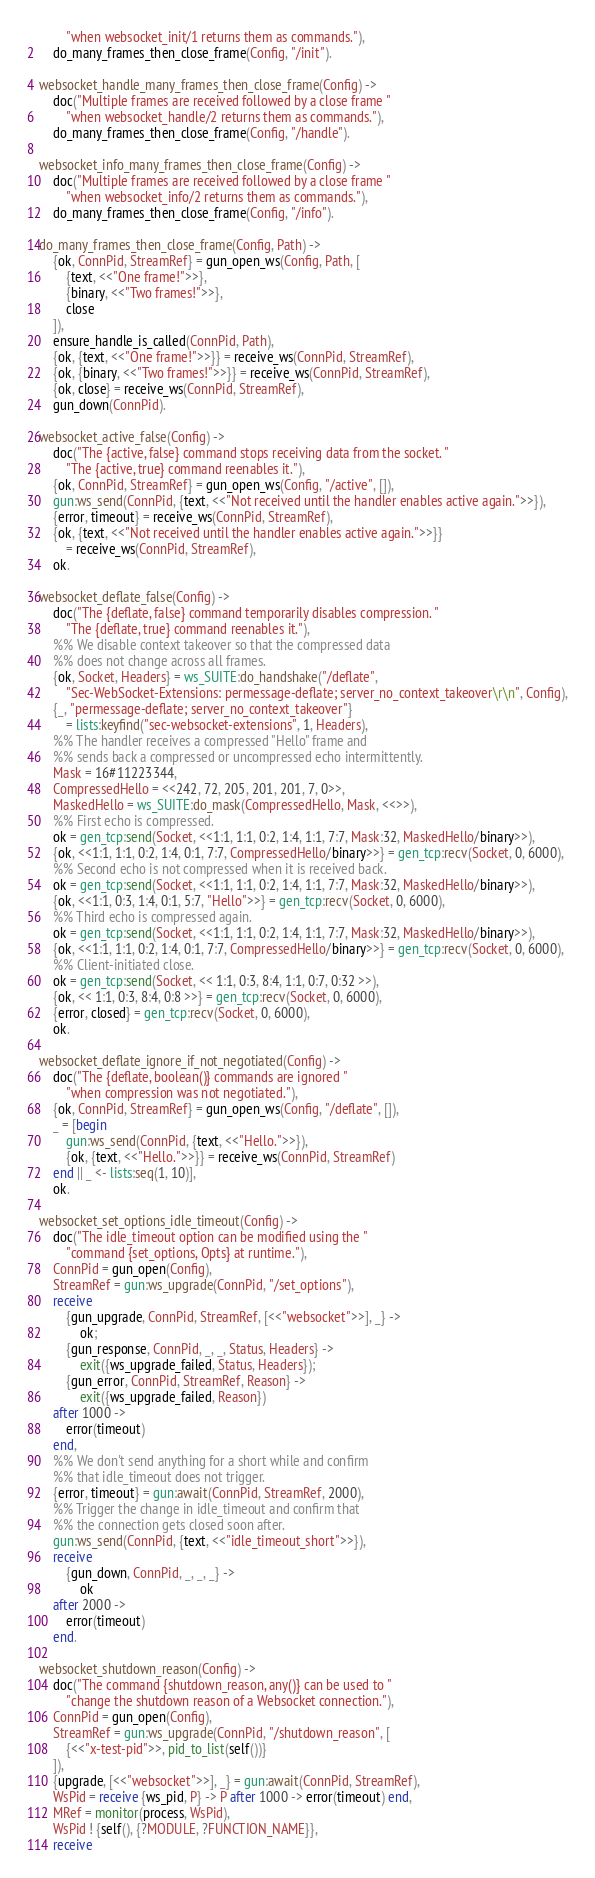<code> <loc_0><loc_0><loc_500><loc_500><_Erlang_>		"when websocket_init/1 returns them as commands."),
	do_many_frames_then_close_frame(Config, "/init").

websocket_handle_many_frames_then_close_frame(Config) ->
	doc("Multiple frames are received followed by a close frame "
		"when websocket_handle/2 returns them as commands."),
	do_many_frames_then_close_frame(Config, "/handle").

websocket_info_many_frames_then_close_frame(Config) ->
	doc("Multiple frames are received followed by a close frame "
		"when websocket_info/2 returns them as commands."),
	do_many_frames_then_close_frame(Config, "/info").

do_many_frames_then_close_frame(Config, Path) ->
	{ok, ConnPid, StreamRef} = gun_open_ws(Config, Path, [
		{text, <<"One frame!">>},
		{binary, <<"Two frames!">>},
		close
	]),
	ensure_handle_is_called(ConnPid, Path),
	{ok, {text, <<"One frame!">>}} = receive_ws(ConnPid, StreamRef),
	{ok, {binary, <<"Two frames!">>}} = receive_ws(ConnPid, StreamRef),
	{ok, close} = receive_ws(ConnPid, StreamRef),
	gun_down(ConnPid).

websocket_active_false(Config) ->
	doc("The {active, false} command stops receiving data from the socket. "
		"The {active, true} command reenables it."),
	{ok, ConnPid, StreamRef} = gun_open_ws(Config, "/active", []),
	gun:ws_send(ConnPid, {text, <<"Not received until the handler enables active again.">>}),
	{error, timeout} = receive_ws(ConnPid, StreamRef),
	{ok, {text, <<"Not received until the handler enables active again.">>}}
		= receive_ws(ConnPid, StreamRef),
	ok.

websocket_deflate_false(Config) ->
	doc("The {deflate, false} command temporarily disables compression. "
		"The {deflate, true} command reenables it."),
	%% We disable context takeover so that the compressed data
	%% does not change across all frames.
	{ok, Socket, Headers} = ws_SUITE:do_handshake("/deflate",
		"Sec-WebSocket-Extensions: permessage-deflate; server_no_context_takeover\r\n", Config),
	{_, "permessage-deflate; server_no_context_takeover"}
		= lists:keyfind("sec-websocket-extensions", 1, Headers),
	%% The handler receives a compressed "Hello" frame and
	%% sends back a compressed or uncompressed echo intermittently.
	Mask = 16#11223344,
	CompressedHello = <<242, 72, 205, 201, 201, 7, 0>>,
	MaskedHello = ws_SUITE:do_mask(CompressedHello, Mask, <<>>),
	%% First echo is compressed.
	ok = gen_tcp:send(Socket, <<1:1, 1:1, 0:2, 1:4, 1:1, 7:7, Mask:32, MaskedHello/binary>>),
	{ok, <<1:1, 1:1, 0:2, 1:4, 0:1, 7:7, CompressedHello/binary>>} = gen_tcp:recv(Socket, 0, 6000),
	%% Second echo is not compressed when it is received back.
	ok = gen_tcp:send(Socket, <<1:1, 1:1, 0:2, 1:4, 1:1, 7:7, Mask:32, MaskedHello/binary>>),
	{ok, <<1:1, 0:3, 1:4, 0:1, 5:7, "Hello">>} = gen_tcp:recv(Socket, 0, 6000),
	%% Third echo is compressed again.
	ok = gen_tcp:send(Socket, <<1:1, 1:1, 0:2, 1:4, 1:1, 7:7, Mask:32, MaskedHello/binary>>),
	{ok, <<1:1, 1:1, 0:2, 1:4, 0:1, 7:7, CompressedHello/binary>>} = gen_tcp:recv(Socket, 0, 6000),
	%% Client-initiated close.
	ok = gen_tcp:send(Socket, << 1:1, 0:3, 8:4, 1:1, 0:7, 0:32 >>),
	{ok, << 1:1, 0:3, 8:4, 0:8 >>} = gen_tcp:recv(Socket, 0, 6000),
	{error, closed} = gen_tcp:recv(Socket, 0, 6000),
	ok.

websocket_deflate_ignore_if_not_negotiated(Config) ->
	doc("The {deflate, boolean()} commands are ignored "
		"when compression was not negotiated."),
	{ok, ConnPid, StreamRef} = gun_open_ws(Config, "/deflate", []),
	_ = [begin
		gun:ws_send(ConnPid, {text, <<"Hello.">>}),
		{ok, {text, <<"Hello.">>}} = receive_ws(ConnPid, StreamRef)
	end || _ <- lists:seq(1, 10)],
	ok.

websocket_set_options_idle_timeout(Config) ->
	doc("The idle_timeout option can be modified using the "
		"command {set_options, Opts} at runtime."),
	ConnPid = gun_open(Config),
	StreamRef = gun:ws_upgrade(ConnPid, "/set_options"),
	receive
		{gun_upgrade, ConnPid, StreamRef, [<<"websocket">>], _} ->
			ok;
		{gun_response, ConnPid, _, _, Status, Headers} ->
			exit({ws_upgrade_failed, Status, Headers});
		{gun_error, ConnPid, StreamRef, Reason} ->
			exit({ws_upgrade_failed, Reason})
	after 1000 ->
		error(timeout)
	end,
	%% We don't send anything for a short while and confirm
	%% that idle_timeout does not trigger.
	{error, timeout} = gun:await(ConnPid, StreamRef, 2000),
	%% Trigger the change in idle_timeout and confirm that
	%% the connection gets closed soon after.
	gun:ws_send(ConnPid, {text, <<"idle_timeout_short">>}),
	receive
		{gun_down, ConnPid, _, _, _} ->
			ok
	after 2000 ->
		error(timeout)
	end.

websocket_shutdown_reason(Config) ->
	doc("The command {shutdown_reason, any()} can be used to "
		"change the shutdown reason of a Websocket connection."),
	ConnPid = gun_open(Config),
	StreamRef = gun:ws_upgrade(ConnPid, "/shutdown_reason", [
		{<<"x-test-pid">>, pid_to_list(self())}
	]),
	{upgrade, [<<"websocket">>], _} = gun:await(ConnPid, StreamRef),
	WsPid = receive {ws_pid, P} -> P after 1000 -> error(timeout) end,
	MRef = monitor(process, WsPid),
	WsPid ! {self(), {?MODULE, ?FUNCTION_NAME}},
	receive</code> 